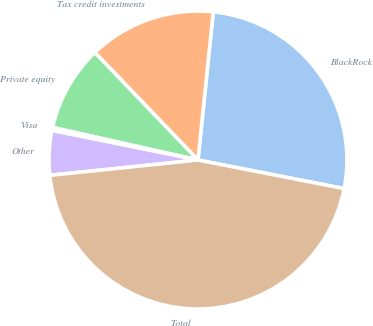Convert chart to OTSL. <chart><loc_0><loc_0><loc_500><loc_500><pie_chart><fcel>BlackRock<fcel>Tax credit investments<fcel>Private equity<fcel>Visa<fcel>Other<fcel>Total<nl><fcel>26.44%<fcel>13.81%<fcel>9.32%<fcel>0.33%<fcel>4.82%<fcel>45.28%<nl></chart> 